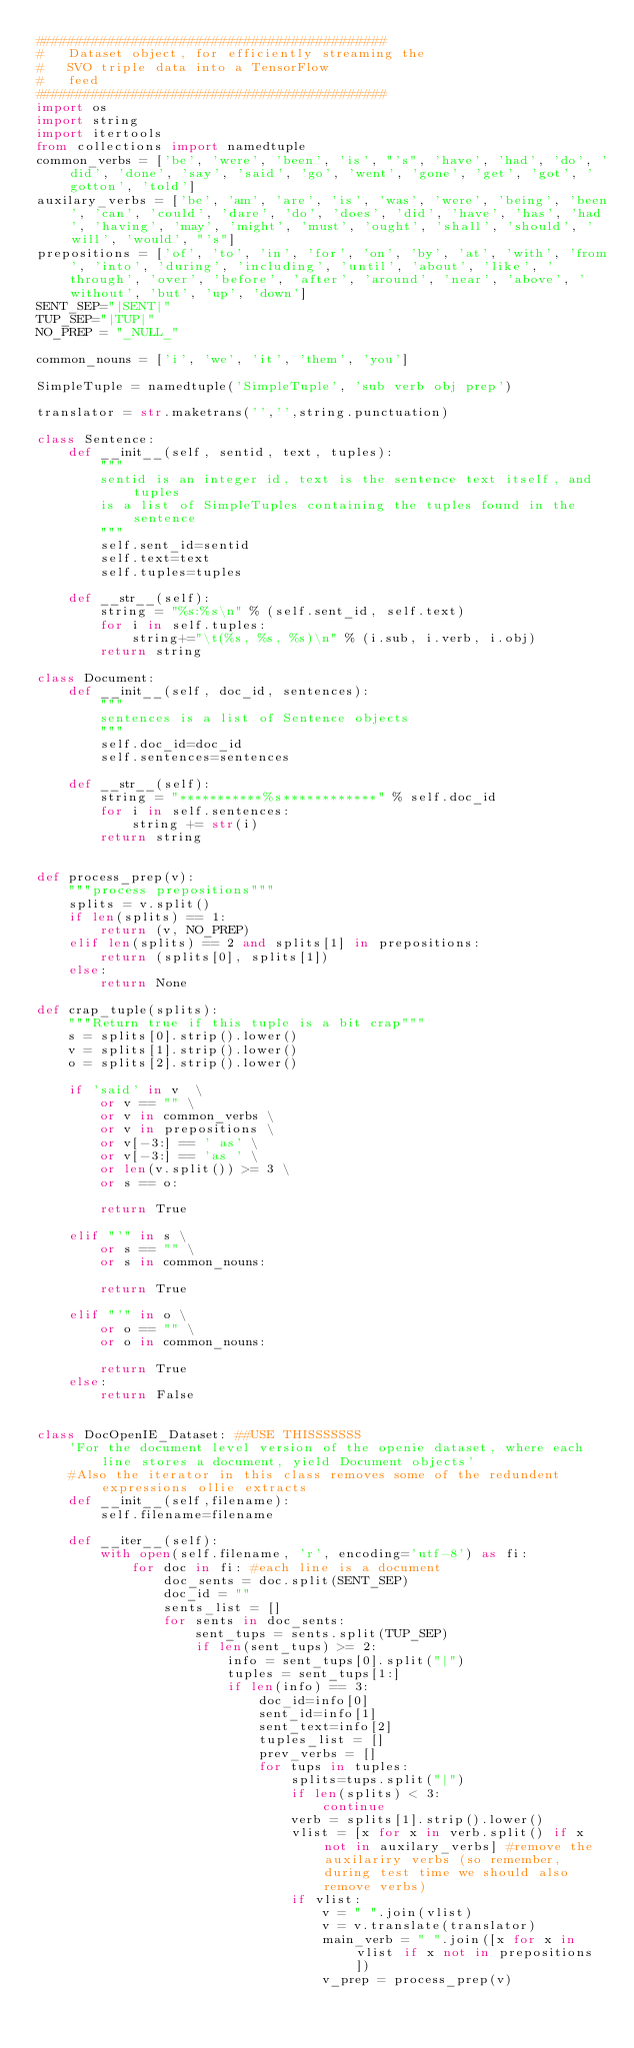<code> <loc_0><loc_0><loc_500><loc_500><_Python_>############################################
#   Dataset object, for efficiently streaming the
#   SVO triple data into a TensorFlow
#   feed
############################################
import os
import string
import itertools
from collections import namedtuple
common_verbs = ['be', 'were', 'been', 'is', "'s", 'have', 'had', 'do', 'did', 'done', 'say', 'said', 'go', 'went', 'gone', 'get', 'got', 'gotton', 'told']
auxilary_verbs = ['be', 'am', 'are', 'is', 'was', 'were', 'being', 'been', 'can', 'could', 'dare', 'do', 'does', 'did', 'have', 'has', 'had', 'having', 'may', 'might', 'must', 'ought', 'shall', 'should', 'will', 'would', "'s"]
prepositions = ['of', 'to', 'in', 'for', 'on', 'by', 'at', 'with', 'from', 'into', 'during', 'including', 'until', 'about', 'like', 'through', 'over', 'before', 'after', 'around', 'near', 'above', 'without', 'but', 'up', 'down']
SENT_SEP="|SENT|"
TUP_SEP="|TUP|"
NO_PREP = "_NULL_"

common_nouns = ['i', 'we', 'it', 'them', 'you']

SimpleTuple = namedtuple('SimpleTuple', 'sub verb obj prep')

translator = str.maketrans('','',string.punctuation)

class Sentence:
    def __init__(self, sentid, text, tuples):
        """
        sentid is an integer id, text is the sentence text itself, and tuples
        is a list of SimpleTuples containing the tuples found in the sentence
        """
        self.sent_id=sentid
        self.text=text
        self.tuples=tuples

    def __str__(self):
        string = "%s:%s\n" % (self.sent_id, self.text)
        for i in self.tuples:
            string+="\t(%s, %s, %s)\n" % (i.sub, i.verb, i.obj)
        return string
 
class Document:
    def __init__(self, doc_id, sentences):
        """
        sentences is a list of Sentence objects
        """
        self.doc_id=doc_id
        self.sentences=sentences

    def __str__(self):
        string = "***********%s************" % self.doc_id
        for i in self.sentences:
            string += str(i)
        return string


def process_prep(v):
    """process prepositions"""
    splits = v.split()
    if len(splits) == 1:
        return (v, NO_PREP)
    elif len(splits) == 2 and splits[1] in prepositions:
        return (splits[0], splits[1])
    else:
        return None
        
def crap_tuple(splits):
    """Return true if this tuple is a bit crap"""
    s = splits[0].strip().lower()
    v = splits[1].strip().lower()
    o = splits[2].strip().lower()

    if 'said' in v  \
        or v == "" \
        or v in common_verbs \
        or v in prepositions \
        or v[-3:] == ' as' \
        or v[-3:] == 'as ' \
        or len(v.split()) >= 3 \
        or s == o:

        return True

    elif "'" in s \
        or s == "" \
        or s in common_nouns:

        return True

    elif "'" in o \
        or o == "" \
        or o in common_nouns:

        return True
    else:
        return False


class DocOpenIE_Dataset: ##USE THISSSSSSS
    'For the document level version of the openie dataset, where each line stores a document, yield Document objects' 
    #Also the iterator in this class removes some of the redundent expressions ollie extracts
    def __init__(self,filename):
        self.filename=filename

    def __iter__(self):
        with open(self.filename, 'r', encoding='utf-8') as fi:
            for doc in fi: #each line is a document
                doc_sents = doc.split(SENT_SEP)
                doc_id = ""
                sents_list = []
                for sents in doc_sents:
                    sent_tups = sents.split(TUP_SEP)
                    if len(sent_tups) >= 2:
                        info = sent_tups[0].split("|")
                        tuples = sent_tups[1:]
                        if len(info) == 3: 
                            doc_id=info[0]
                            sent_id=info[1]
                            sent_text=info[2]
                            tuples_list = []
                            prev_verbs = []
                            for tups in tuples:
                                splits=tups.split("|")
                                if len(splits) < 3:
                                    continue
                                verb = splits[1].strip().lower()
                                vlist = [x for x in verb.split() if x not in auxilary_verbs] #remove the auxilariry verbs (so remember, during test time we should also remove verbs)
                                if vlist:
                                    v = " ".join(vlist)
                                    v = v.translate(translator)
                                    main_verb = " ".join([x for x in vlist if x not in prepositions])
                                    v_prep = process_prep(v)</code> 